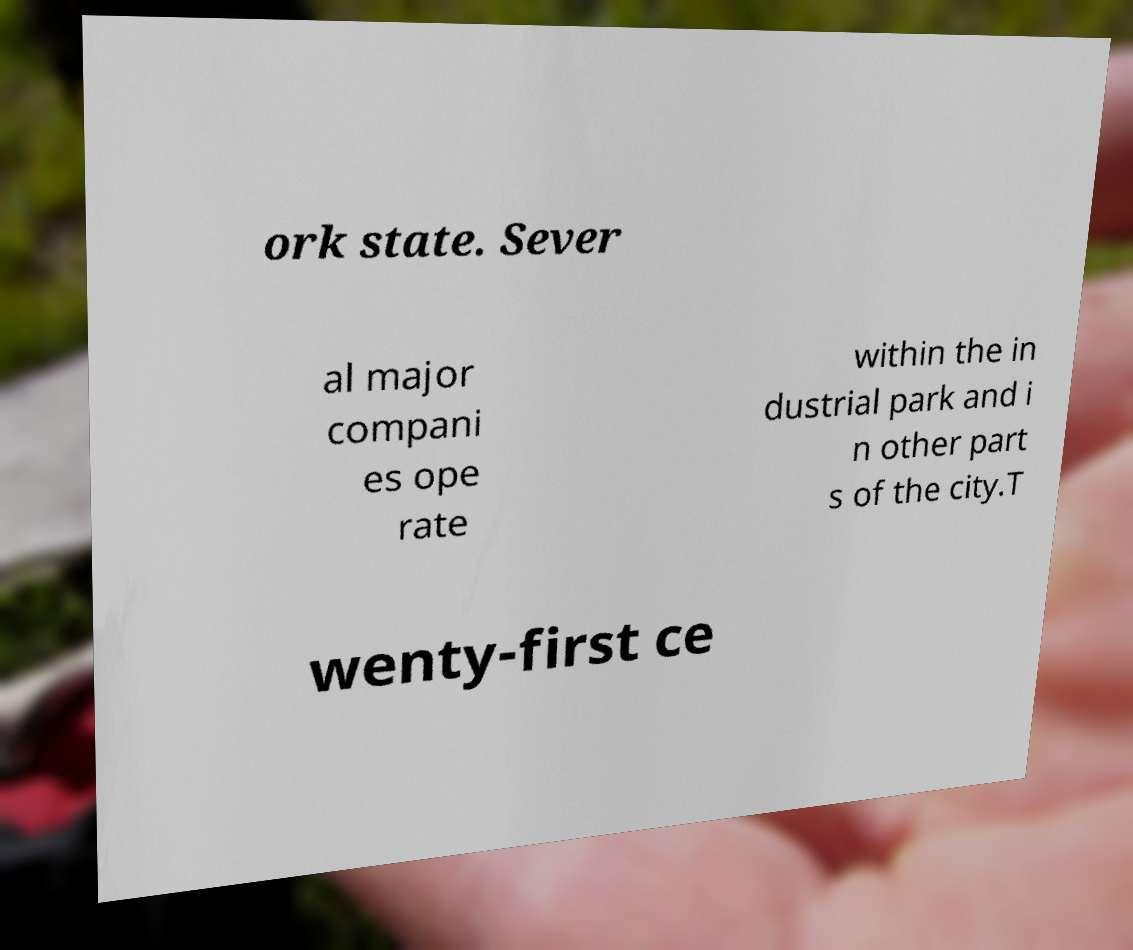I need the written content from this picture converted into text. Can you do that? ork state. Sever al major compani es ope rate within the in dustrial park and i n other part s of the city.T wenty-first ce 